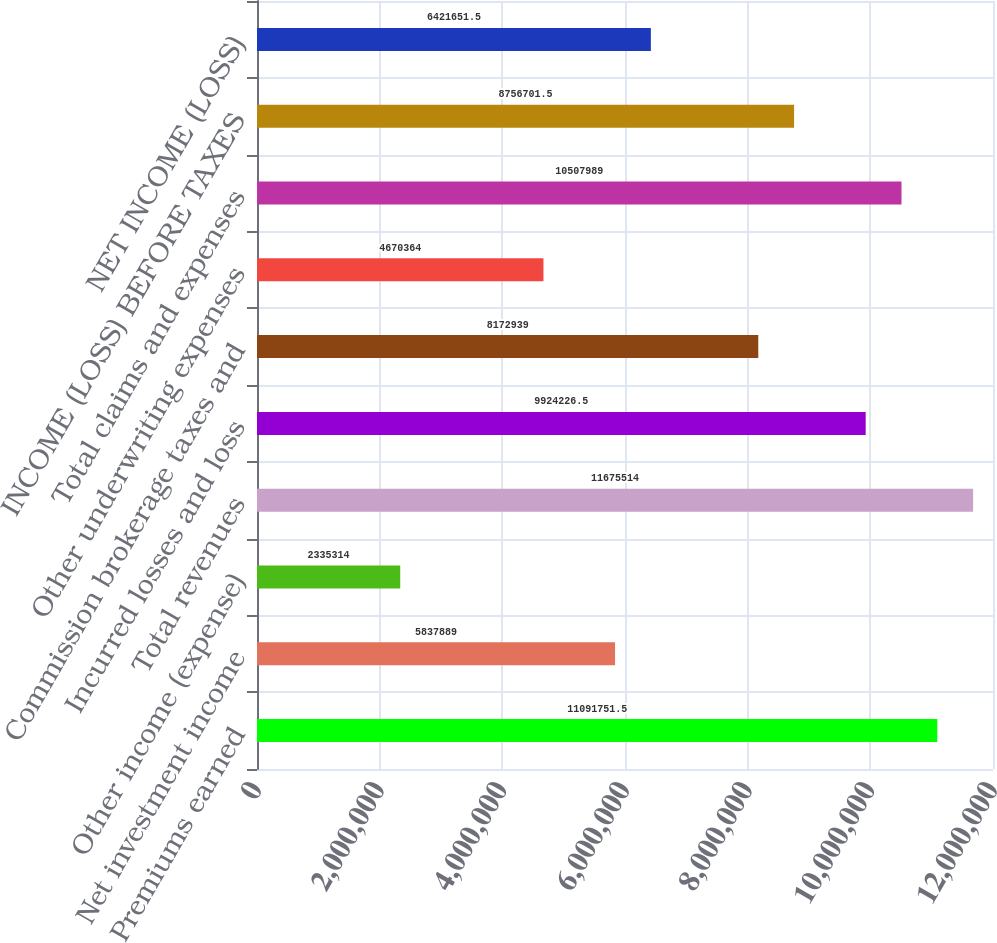Convert chart. <chart><loc_0><loc_0><loc_500><loc_500><bar_chart><fcel>Premiums earned<fcel>Net investment income<fcel>Other income (expense)<fcel>Total revenues<fcel>Incurred losses and loss<fcel>Commission brokerage taxes and<fcel>Other underwriting expenses<fcel>Total claims and expenses<fcel>INCOME (LOSS) BEFORE TAXES<fcel>NET INCOME (LOSS)<nl><fcel>1.10918e+07<fcel>5.83789e+06<fcel>2.33531e+06<fcel>1.16755e+07<fcel>9.92423e+06<fcel>8.17294e+06<fcel>4.67036e+06<fcel>1.0508e+07<fcel>8.7567e+06<fcel>6.42165e+06<nl></chart> 